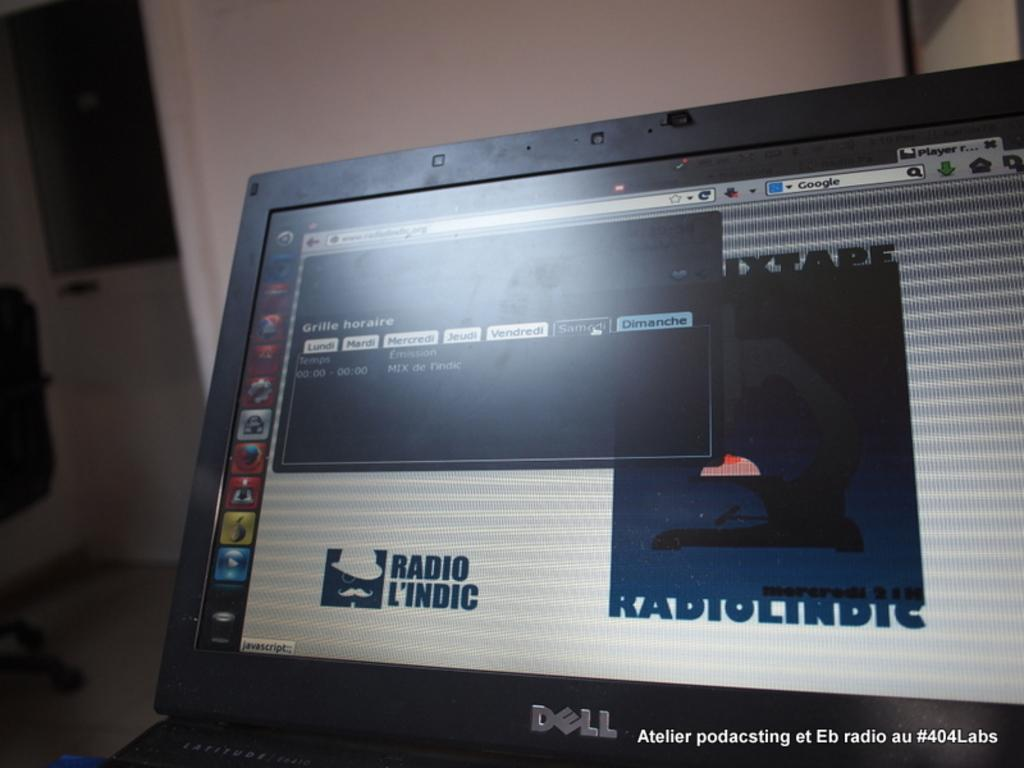<image>
Describe the image concisely. A dell laptop screen displaying Radio L'indic logo on it. 